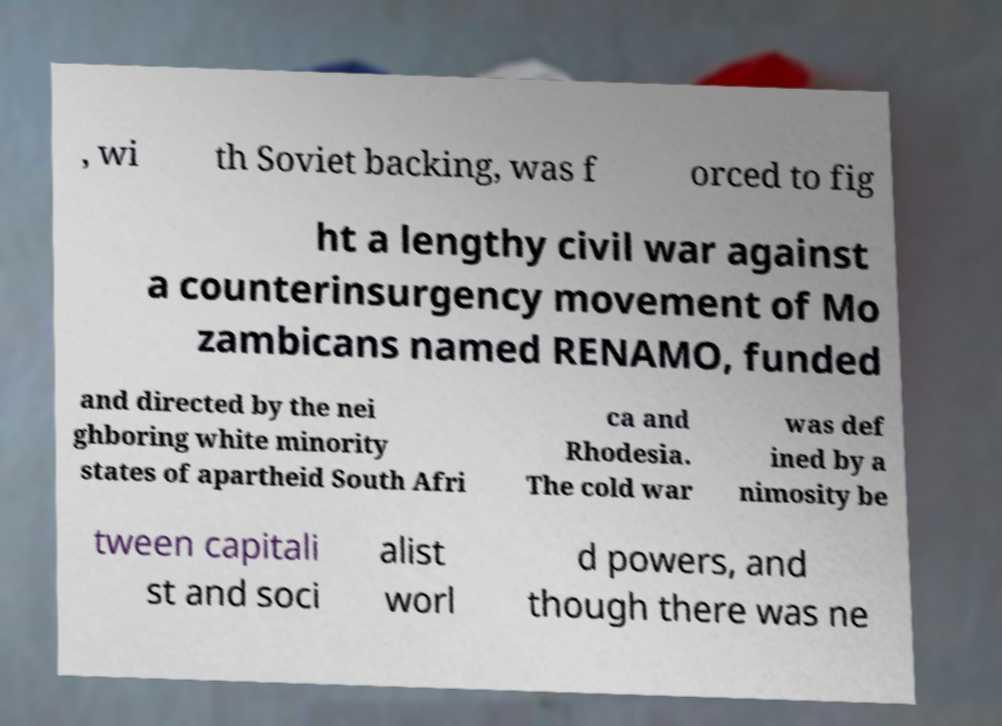Could you extract and type out the text from this image? , wi th Soviet backing, was f orced to fig ht a lengthy civil war against a counterinsurgency movement of Mo zambicans named RENAMO, funded and directed by the nei ghboring white minority states of apartheid South Afri ca and Rhodesia. The cold war was def ined by a nimosity be tween capitali st and soci alist worl d powers, and though there was ne 